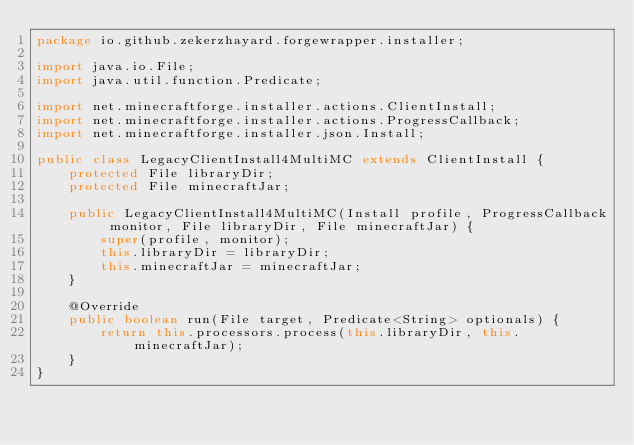Convert code to text. <code><loc_0><loc_0><loc_500><loc_500><_Java_>package io.github.zekerzhayard.forgewrapper.installer;

import java.io.File;
import java.util.function.Predicate;

import net.minecraftforge.installer.actions.ClientInstall;
import net.minecraftforge.installer.actions.ProgressCallback;
import net.minecraftforge.installer.json.Install;

public class LegacyClientInstall4MultiMC extends ClientInstall {
    protected File libraryDir;
    protected File minecraftJar;

    public LegacyClientInstall4MultiMC(Install profile, ProgressCallback monitor, File libraryDir, File minecraftJar) {
        super(profile, monitor);
        this.libraryDir = libraryDir;
        this.minecraftJar = minecraftJar;
    }

    @Override
    public boolean run(File target, Predicate<String> optionals) {
        return this.processors.process(this.libraryDir, this.minecraftJar);
    }
}
</code> 